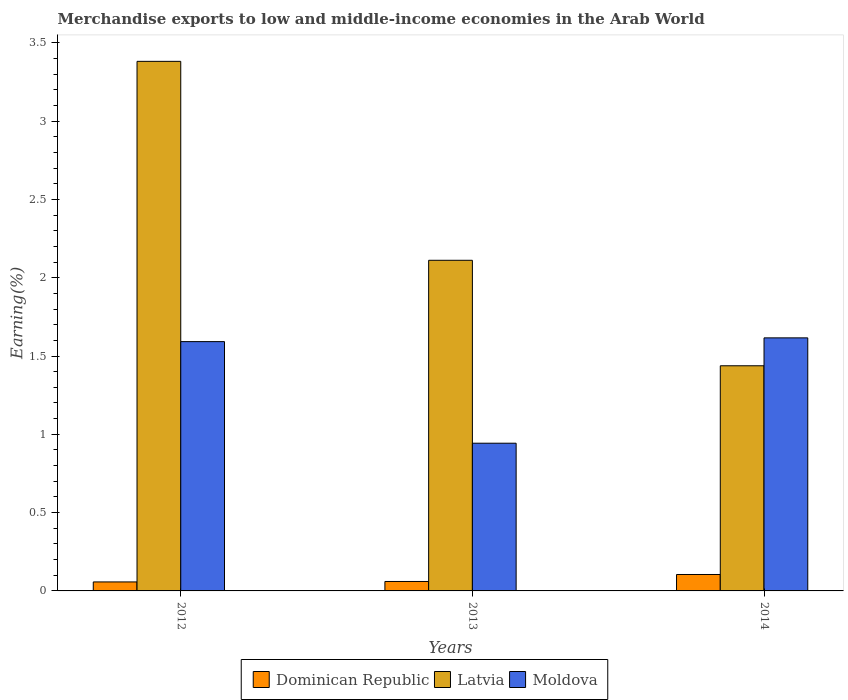Are the number of bars on each tick of the X-axis equal?
Offer a very short reply. Yes. How many bars are there on the 2nd tick from the right?
Offer a terse response. 3. In how many cases, is the number of bars for a given year not equal to the number of legend labels?
Provide a short and direct response. 0. What is the percentage of amount earned from merchandise exports in Latvia in 2014?
Offer a very short reply. 1.44. Across all years, what is the maximum percentage of amount earned from merchandise exports in Dominican Republic?
Provide a short and direct response. 0.1. Across all years, what is the minimum percentage of amount earned from merchandise exports in Moldova?
Your response must be concise. 0.94. In which year was the percentage of amount earned from merchandise exports in Dominican Republic maximum?
Your answer should be compact. 2014. In which year was the percentage of amount earned from merchandise exports in Dominican Republic minimum?
Provide a short and direct response. 2012. What is the total percentage of amount earned from merchandise exports in Dominican Republic in the graph?
Offer a very short reply. 0.22. What is the difference between the percentage of amount earned from merchandise exports in Moldova in 2012 and that in 2013?
Provide a short and direct response. 0.65. What is the difference between the percentage of amount earned from merchandise exports in Moldova in 2014 and the percentage of amount earned from merchandise exports in Latvia in 2013?
Your answer should be very brief. -0.5. What is the average percentage of amount earned from merchandise exports in Latvia per year?
Your answer should be compact. 2.31. In the year 2014, what is the difference between the percentage of amount earned from merchandise exports in Moldova and percentage of amount earned from merchandise exports in Latvia?
Your answer should be compact. 0.18. In how many years, is the percentage of amount earned from merchandise exports in Dominican Republic greater than 2.6 %?
Keep it short and to the point. 0. What is the ratio of the percentage of amount earned from merchandise exports in Moldova in 2012 to that in 2014?
Your answer should be compact. 0.99. What is the difference between the highest and the second highest percentage of amount earned from merchandise exports in Dominican Republic?
Your response must be concise. 0.04. What is the difference between the highest and the lowest percentage of amount earned from merchandise exports in Moldova?
Your response must be concise. 0.67. Is the sum of the percentage of amount earned from merchandise exports in Moldova in 2013 and 2014 greater than the maximum percentage of amount earned from merchandise exports in Latvia across all years?
Give a very brief answer. No. What does the 1st bar from the left in 2014 represents?
Make the answer very short. Dominican Republic. What does the 2nd bar from the right in 2012 represents?
Your response must be concise. Latvia. Is it the case that in every year, the sum of the percentage of amount earned from merchandise exports in Latvia and percentage of amount earned from merchandise exports in Moldova is greater than the percentage of amount earned from merchandise exports in Dominican Republic?
Make the answer very short. Yes. Are all the bars in the graph horizontal?
Offer a terse response. No. How many years are there in the graph?
Your answer should be compact. 3. Does the graph contain any zero values?
Your answer should be compact. No. Does the graph contain grids?
Offer a very short reply. No. Where does the legend appear in the graph?
Make the answer very short. Bottom center. How many legend labels are there?
Give a very brief answer. 3. What is the title of the graph?
Give a very brief answer. Merchandise exports to low and middle-income economies in the Arab World. Does "Sao Tome and Principe" appear as one of the legend labels in the graph?
Ensure brevity in your answer.  No. What is the label or title of the X-axis?
Keep it short and to the point. Years. What is the label or title of the Y-axis?
Make the answer very short. Earning(%). What is the Earning(%) in Dominican Republic in 2012?
Ensure brevity in your answer.  0.06. What is the Earning(%) in Latvia in 2012?
Keep it short and to the point. 3.38. What is the Earning(%) of Moldova in 2012?
Provide a short and direct response. 1.59. What is the Earning(%) of Dominican Republic in 2013?
Offer a terse response. 0.06. What is the Earning(%) in Latvia in 2013?
Offer a terse response. 2.11. What is the Earning(%) in Moldova in 2013?
Offer a terse response. 0.94. What is the Earning(%) in Dominican Republic in 2014?
Offer a very short reply. 0.1. What is the Earning(%) of Latvia in 2014?
Your answer should be very brief. 1.44. What is the Earning(%) of Moldova in 2014?
Your answer should be compact. 1.62. Across all years, what is the maximum Earning(%) in Dominican Republic?
Make the answer very short. 0.1. Across all years, what is the maximum Earning(%) in Latvia?
Keep it short and to the point. 3.38. Across all years, what is the maximum Earning(%) in Moldova?
Your response must be concise. 1.62. Across all years, what is the minimum Earning(%) of Dominican Republic?
Offer a terse response. 0.06. Across all years, what is the minimum Earning(%) in Latvia?
Provide a short and direct response. 1.44. Across all years, what is the minimum Earning(%) in Moldova?
Your answer should be very brief. 0.94. What is the total Earning(%) of Dominican Republic in the graph?
Provide a succinct answer. 0.22. What is the total Earning(%) of Latvia in the graph?
Your answer should be compact. 6.93. What is the total Earning(%) in Moldova in the graph?
Give a very brief answer. 4.15. What is the difference between the Earning(%) of Dominican Republic in 2012 and that in 2013?
Offer a terse response. -0. What is the difference between the Earning(%) of Latvia in 2012 and that in 2013?
Offer a terse response. 1.27. What is the difference between the Earning(%) in Moldova in 2012 and that in 2013?
Make the answer very short. 0.65. What is the difference between the Earning(%) in Dominican Republic in 2012 and that in 2014?
Provide a short and direct response. -0.05. What is the difference between the Earning(%) in Latvia in 2012 and that in 2014?
Keep it short and to the point. 1.94. What is the difference between the Earning(%) of Moldova in 2012 and that in 2014?
Ensure brevity in your answer.  -0.02. What is the difference between the Earning(%) of Dominican Republic in 2013 and that in 2014?
Provide a short and direct response. -0.04. What is the difference between the Earning(%) in Latvia in 2013 and that in 2014?
Your answer should be very brief. 0.67. What is the difference between the Earning(%) in Moldova in 2013 and that in 2014?
Your response must be concise. -0.67. What is the difference between the Earning(%) of Dominican Republic in 2012 and the Earning(%) of Latvia in 2013?
Your answer should be compact. -2.05. What is the difference between the Earning(%) of Dominican Republic in 2012 and the Earning(%) of Moldova in 2013?
Ensure brevity in your answer.  -0.89. What is the difference between the Earning(%) of Latvia in 2012 and the Earning(%) of Moldova in 2013?
Offer a terse response. 2.44. What is the difference between the Earning(%) in Dominican Republic in 2012 and the Earning(%) in Latvia in 2014?
Your answer should be very brief. -1.38. What is the difference between the Earning(%) in Dominican Republic in 2012 and the Earning(%) in Moldova in 2014?
Make the answer very short. -1.56. What is the difference between the Earning(%) in Latvia in 2012 and the Earning(%) in Moldova in 2014?
Provide a succinct answer. 1.77. What is the difference between the Earning(%) of Dominican Republic in 2013 and the Earning(%) of Latvia in 2014?
Make the answer very short. -1.38. What is the difference between the Earning(%) in Dominican Republic in 2013 and the Earning(%) in Moldova in 2014?
Your answer should be compact. -1.56. What is the difference between the Earning(%) in Latvia in 2013 and the Earning(%) in Moldova in 2014?
Provide a succinct answer. 0.5. What is the average Earning(%) of Dominican Republic per year?
Give a very brief answer. 0.07. What is the average Earning(%) of Latvia per year?
Your response must be concise. 2.31. What is the average Earning(%) in Moldova per year?
Give a very brief answer. 1.38. In the year 2012, what is the difference between the Earning(%) in Dominican Republic and Earning(%) in Latvia?
Your response must be concise. -3.32. In the year 2012, what is the difference between the Earning(%) in Dominican Republic and Earning(%) in Moldova?
Your answer should be very brief. -1.53. In the year 2012, what is the difference between the Earning(%) in Latvia and Earning(%) in Moldova?
Provide a succinct answer. 1.79. In the year 2013, what is the difference between the Earning(%) in Dominican Republic and Earning(%) in Latvia?
Offer a very short reply. -2.05. In the year 2013, what is the difference between the Earning(%) of Dominican Republic and Earning(%) of Moldova?
Keep it short and to the point. -0.88. In the year 2013, what is the difference between the Earning(%) in Latvia and Earning(%) in Moldova?
Offer a terse response. 1.17. In the year 2014, what is the difference between the Earning(%) of Dominican Republic and Earning(%) of Latvia?
Your answer should be very brief. -1.33. In the year 2014, what is the difference between the Earning(%) in Dominican Republic and Earning(%) in Moldova?
Provide a short and direct response. -1.51. In the year 2014, what is the difference between the Earning(%) in Latvia and Earning(%) in Moldova?
Provide a short and direct response. -0.18. What is the ratio of the Earning(%) in Dominican Republic in 2012 to that in 2013?
Offer a terse response. 0.95. What is the ratio of the Earning(%) in Latvia in 2012 to that in 2013?
Provide a succinct answer. 1.6. What is the ratio of the Earning(%) in Moldova in 2012 to that in 2013?
Your response must be concise. 1.69. What is the ratio of the Earning(%) in Dominican Republic in 2012 to that in 2014?
Make the answer very short. 0.55. What is the ratio of the Earning(%) in Latvia in 2012 to that in 2014?
Provide a succinct answer. 2.35. What is the ratio of the Earning(%) in Moldova in 2012 to that in 2014?
Your answer should be very brief. 0.99. What is the ratio of the Earning(%) in Dominican Republic in 2013 to that in 2014?
Keep it short and to the point. 0.57. What is the ratio of the Earning(%) in Latvia in 2013 to that in 2014?
Keep it short and to the point. 1.47. What is the ratio of the Earning(%) of Moldova in 2013 to that in 2014?
Offer a terse response. 0.58. What is the difference between the highest and the second highest Earning(%) of Dominican Republic?
Your answer should be very brief. 0.04. What is the difference between the highest and the second highest Earning(%) of Latvia?
Your answer should be very brief. 1.27. What is the difference between the highest and the second highest Earning(%) of Moldova?
Your answer should be compact. 0.02. What is the difference between the highest and the lowest Earning(%) of Dominican Republic?
Provide a short and direct response. 0.05. What is the difference between the highest and the lowest Earning(%) of Latvia?
Keep it short and to the point. 1.94. What is the difference between the highest and the lowest Earning(%) in Moldova?
Your answer should be very brief. 0.67. 